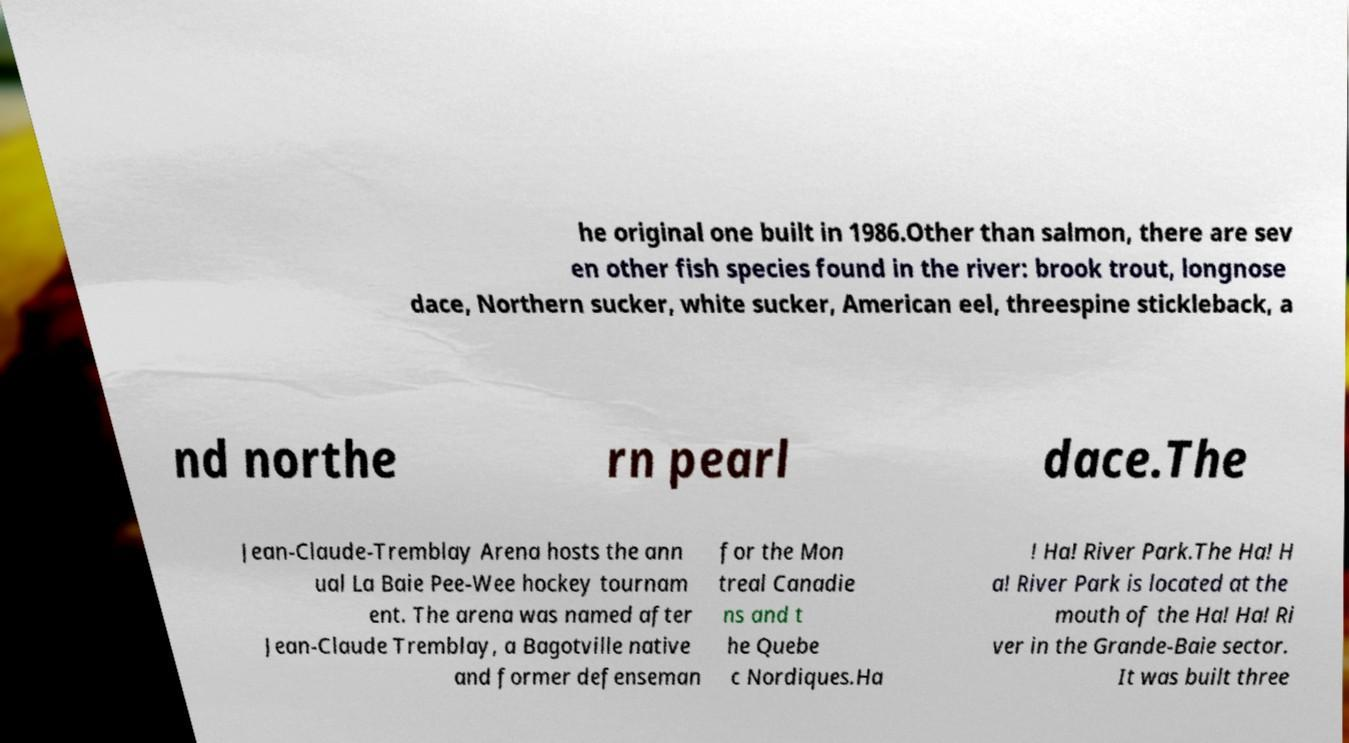Could you extract and type out the text from this image? he original one built in 1986.Other than salmon, there are sev en other fish species found in the river: brook trout, longnose dace, Northern sucker, white sucker, American eel, threespine stickleback, a nd northe rn pearl dace.The Jean-Claude-Tremblay Arena hosts the ann ual La Baie Pee-Wee hockey tournam ent. The arena was named after Jean-Claude Tremblay, a Bagotville native and former defenseman for the Mon treal Canadie ns and t he Quebe c Nordiques.Ha ! Ha! River Park.The Ha! H a! River Park is located at the mouth of the Ha! Ha! Ri ver in the Grande-Baie sector. It was built three 